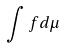Convert formula to latex. <formula><loc_0><loc_0><loc_500><loc_500>\int f d \mu</formula> 